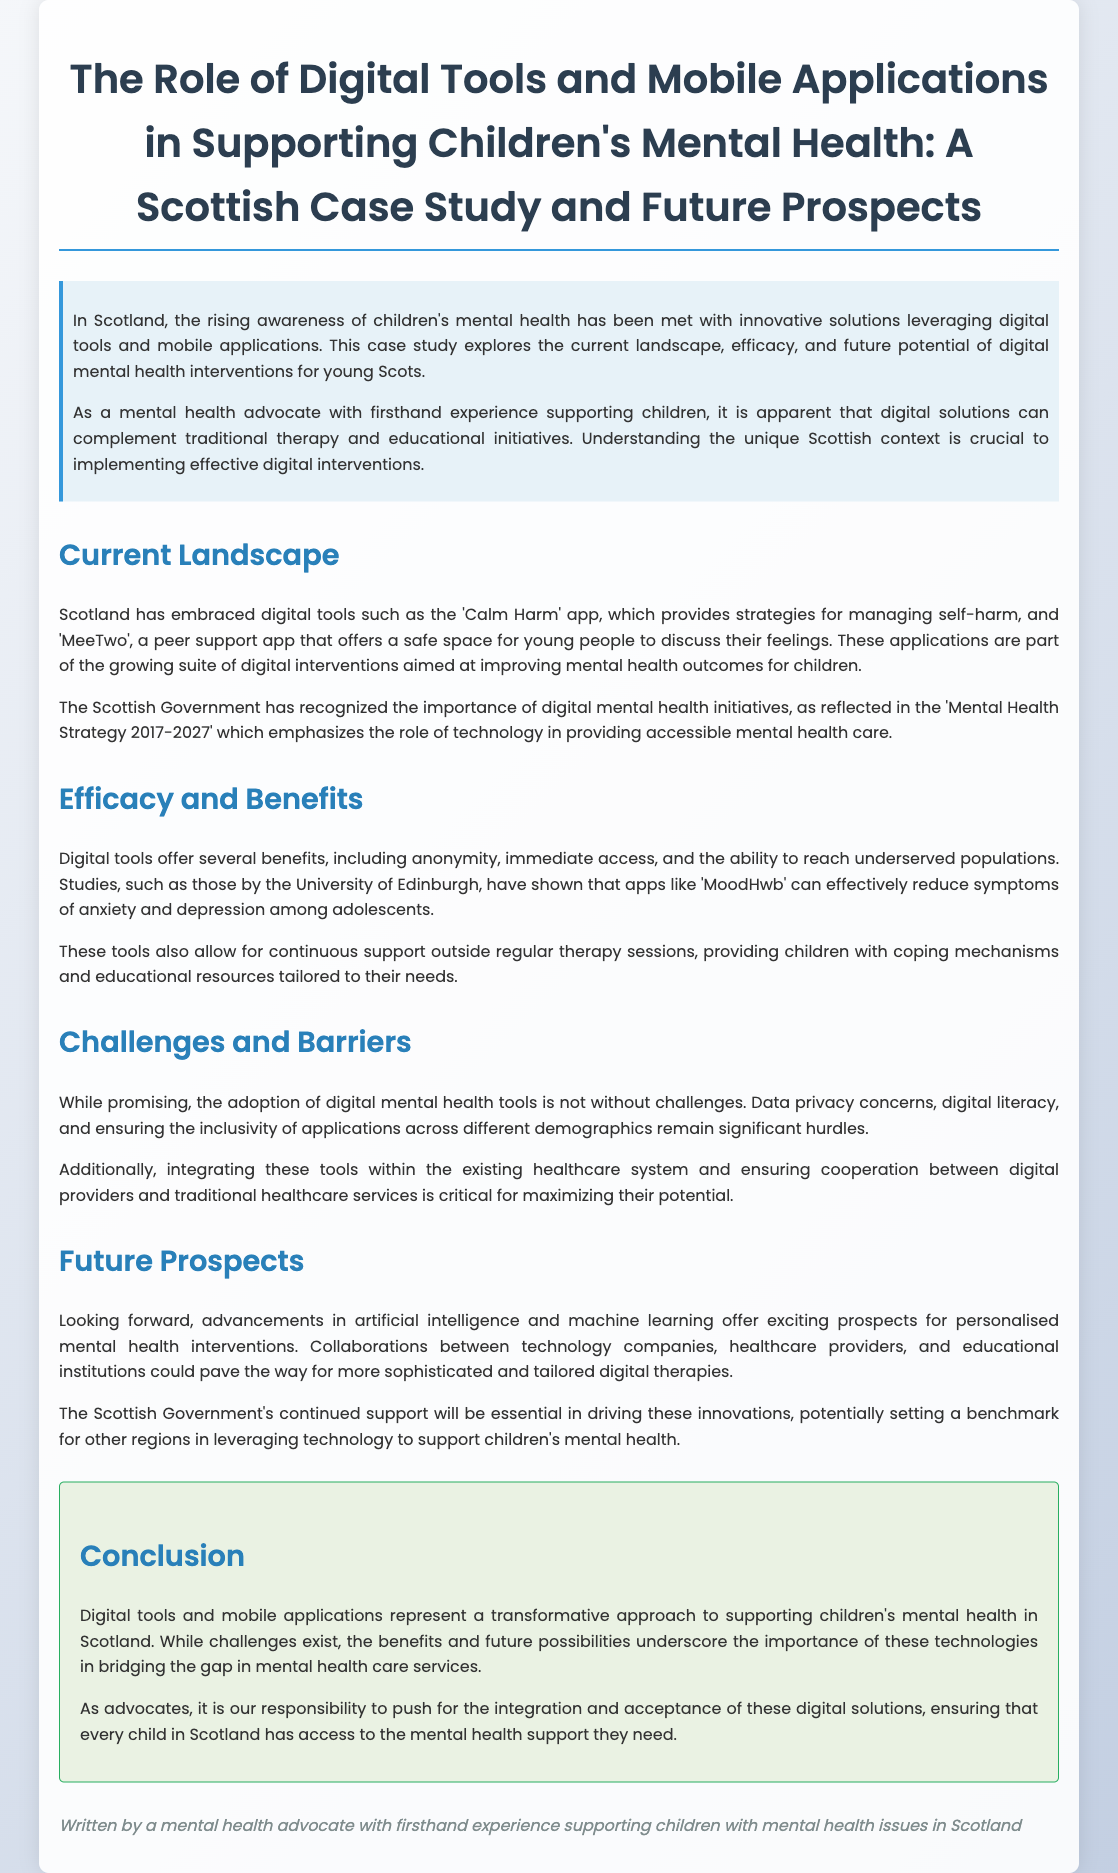What is the title of the whitepaper? The title of the whitepaper is provided at the beginning of the document.
Answer: The Role of Digital Tools and Mobile Applications in Supporting Children's Mental Health: A Scottish Case Study and Future Prospects What application provides strategies for managing self-harm? The document mentions specific applications for supporting children's mental health.
Answer: Calm Harm Which government strategy emphasizes the role of technology in mental health care? The document references a specific government strategy that outlines the importance of technology.
Answer: Mental Health Strategy 2017-2027 What benefit do digital tools offer in terms of access? The document describes certain benefits associated with digital tools.
Answer: Immediate access What is a significant challenge in adopting digital mental health tools? The document highlights challenges faced in the adoption of these tools.
Answer: Data privacy concerns Which university conducted studies on the efficacy of applications like MoodHwb? The document states a specific institution involved in research regarding digital tools.
Answer: University of Edinburgh What is the main focus of the future prospects discussed in the paper? The document outlines future advancements and collaborations regarding digital tools.
Answer: Artificial intelligence What is the document's conclusion regarding digital tools? The conclusion summarizes the overall viewpoint on digital technologies in children's mental health support.
Answer: Transformative approach 